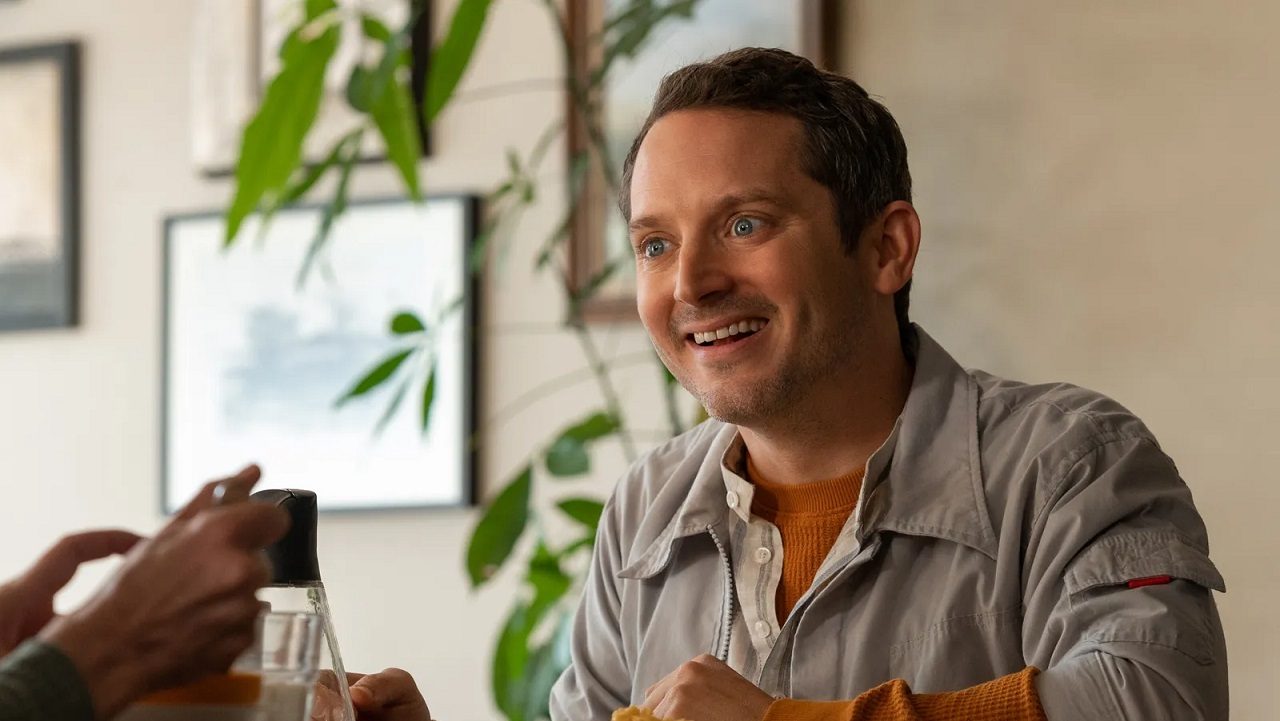Can you describe the mood of the subject and how the environmental elements might be contributing to it? The subject in the image appears to be in a very positive mood, likely enjoying a social interaction based on his broad smile and focused gaze off-camera. The surrounding elements, such as the lush green plants and the soft natural light filtering through the window, contribute to a relaxed and cheerful atmosphere. These elements, combined with the warmth of the indoor setting, enhance the sense of comfort and leisure in the scene. 